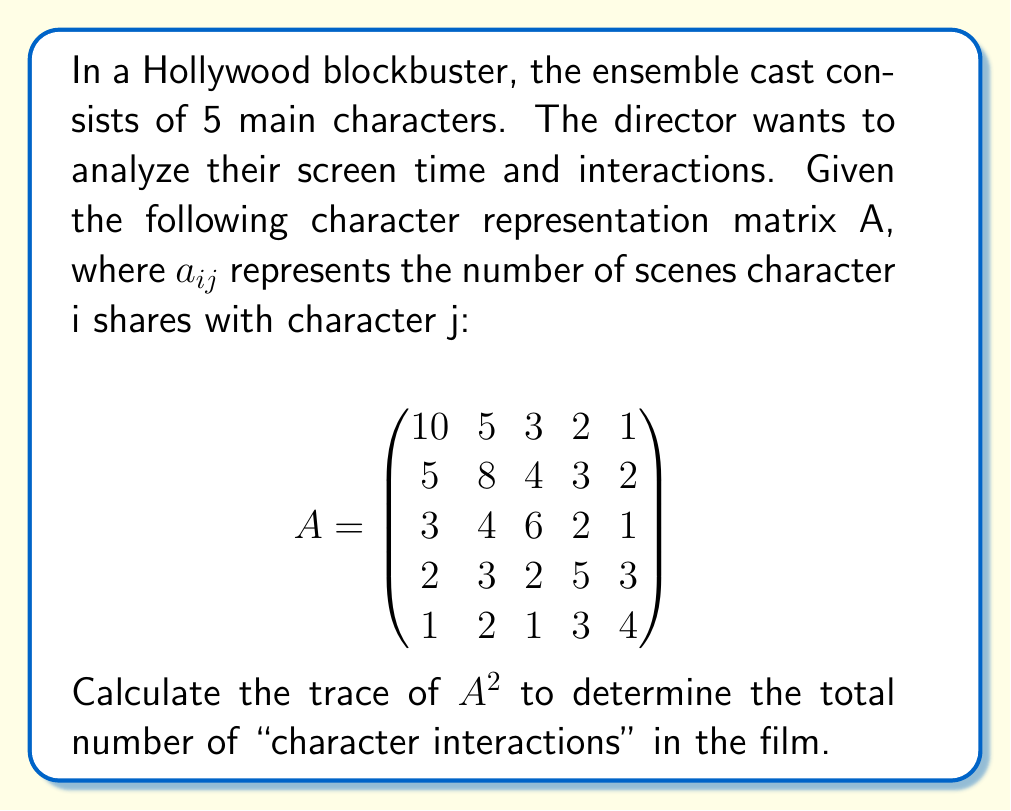What is the answer to this math problem? To solve this problem, we need to follow these steps:

1) First, we need to understand what $A^2$ represents. In this context, $(A^2)_{ij}$ gives the number of "indirect interactions" between character i and character j through a third character.

2) The trace of a matrix is the sum of its diagonal elements. For $A^2$, the diagonal elements represent the sum of squares of direct interactions for each character.

3) Let's calculate $A^2$:

   $$A^2 = \begin{pmatrix}
   10 & 5 & 3 & 2 & 1 \\
   5 & 8 & 4 & 3 & 2 \\
   3 & 4 & 6 & 2 & 1 \\
   2 & 3 & 2 & 5 & 3 \\
   1 & 2 & 1 & 3 & 4
   \end{pmatrix} \times 
   \begin{pmatrix}
   10 & 5 & 3 & 2 & 1 \\
   5 & 8 & 4 & 3 & 2 \\
   3 & 4 & 6 & 2 & 1 \\
   2 & 3 & 2 & 5 & 3 \\
   1 & 2 & 1 & 3 & 4
   \end{pmatrix}$$

4) After multiplication, we get:

   $$A^2 = \begin{pmatrix}
   139 & 102 & 71 & 52 & 35 \\
   102 & 118 & 77 & 61 & 41 \\
   71 & 77 & 70 & 41 & 25 \\
   52 & 61 & 41 & 51 & 37 \\
   35 & 41 & 25 & 37 & 31
   \end{pmatrix}$$

5) The trace of $A^2$ is the sum of its diagonal elements:

   $tr(A^2) = 139 + 118 + 70 + 51 + 31 = 409$

6) This sum represents the total number of "character interactions" in the film, including both direct and indirect interactions.
Answer: 409 